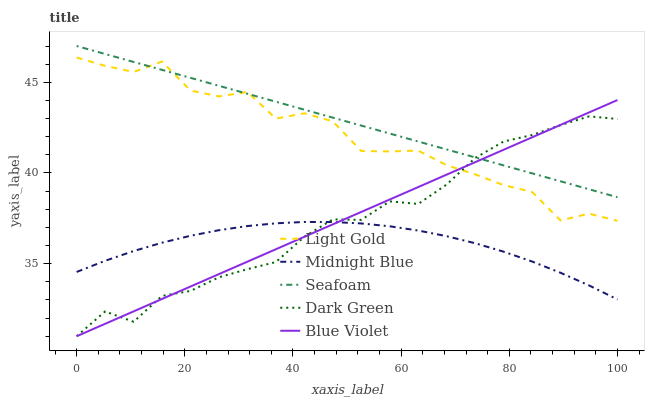Does Midnight Blue have the minimum area under the curve?
Answer yes or no. Yes. Does Seafoam have the maximum area under the curve?
Answer yes or no. Yes. Does Light Gold have the minimum area under the curve?
Answer yes or no. No. Does Light Gold have the maximum area under the curve?
Answer yes or no. No. Is Seafoam the smoothest?
Answer yes or no. Yes. Is Light Gold the roughest?
Answer yes or no. Yes. Is Midnight Blue the smoothest?
Answer yes or no. No. Is Midnight Blue the roughest?
Answer yes or no. No. Does Dark Green have the lowest value?
Answer yes or no. Yes. Does Light Gold have the lowest value?
Answer yes or no. No. Does Seafoam have the highest value?
Answer yes or no. Yes. Does Light Gold have the highest value?
Answer yes or no. No. Is Midnight Blue less than Seafoam?
Answer yes or no. Yes. Is Light Gold greater than Midnight Blue?
Answer yes or no. Yes. Does Blue Violet intersect Midnight Blue?
Answer yes or no. Yes. Is Blue Violet less than Midnight Blue?
Answer yes or no. No. Is Blue Violet greater than Midnight Blue?
Answer yes or no. No. Does Midnight Blue intersect Seafoam?
Answer yes or no. No. 